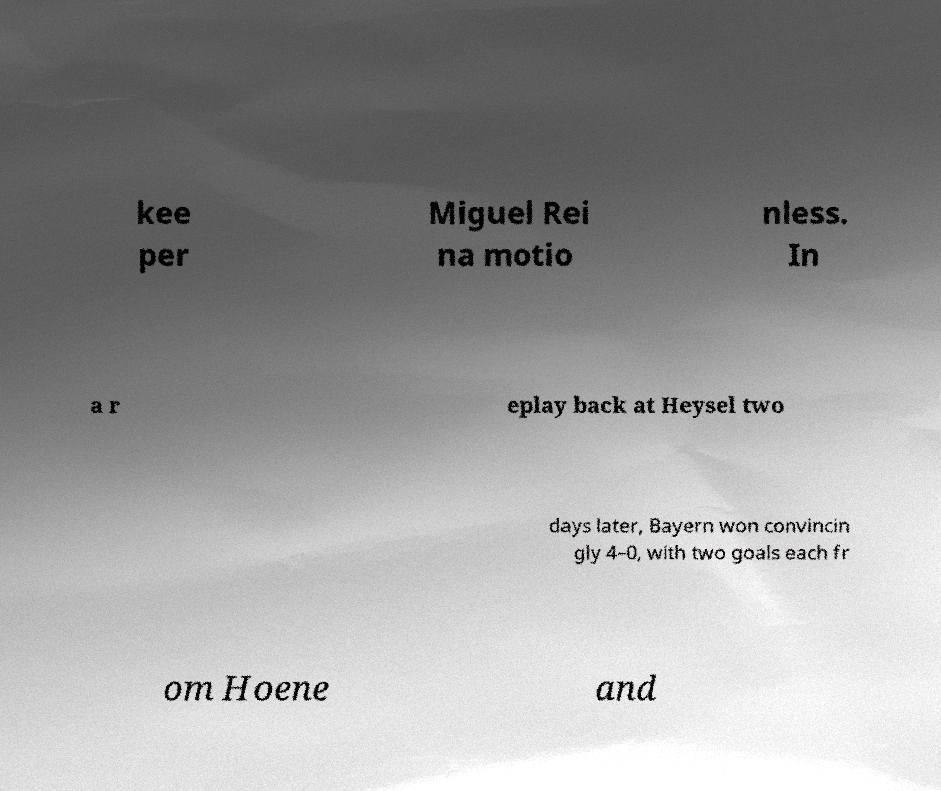Please read and relay the text visible in this image. What does it say? kee per Miguel Rei na motio nless. In a r eplay back at Heysel two days later, Bayern won convincin gly 4–0, with two goals each fr om Hoene and 